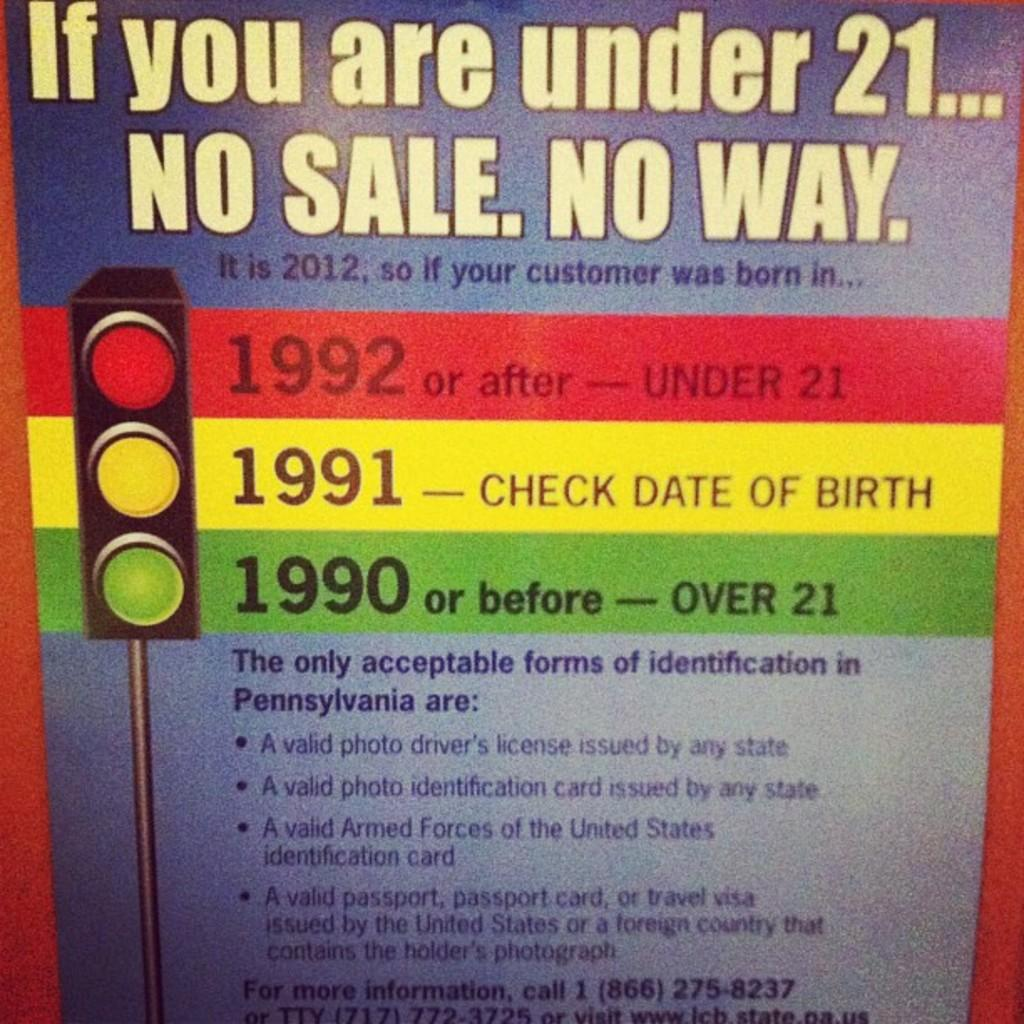Provide a one-sentence caption for the provided image. The year you must have been born after to purchase alcohol. 